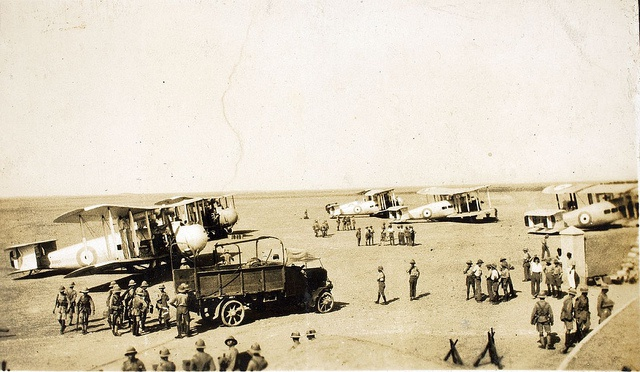Describe the objects in this image and their specific colors. I can see people in beige, tan, black, and gray tones, airplane in lightgray, ivory, black, and tan tones, truck in lightgray, black, and gray tones, airplane in lightgray, tan, beige, and black tones, and airplane in lightgray, beige, tan, and black tones in this image. 